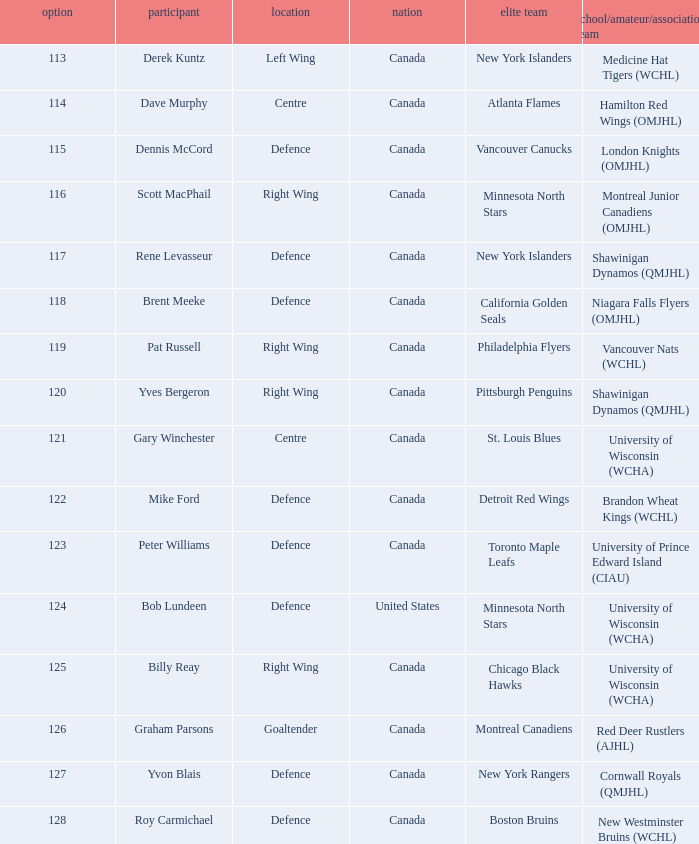Name the player for chicago black hawks Billy Reay. 